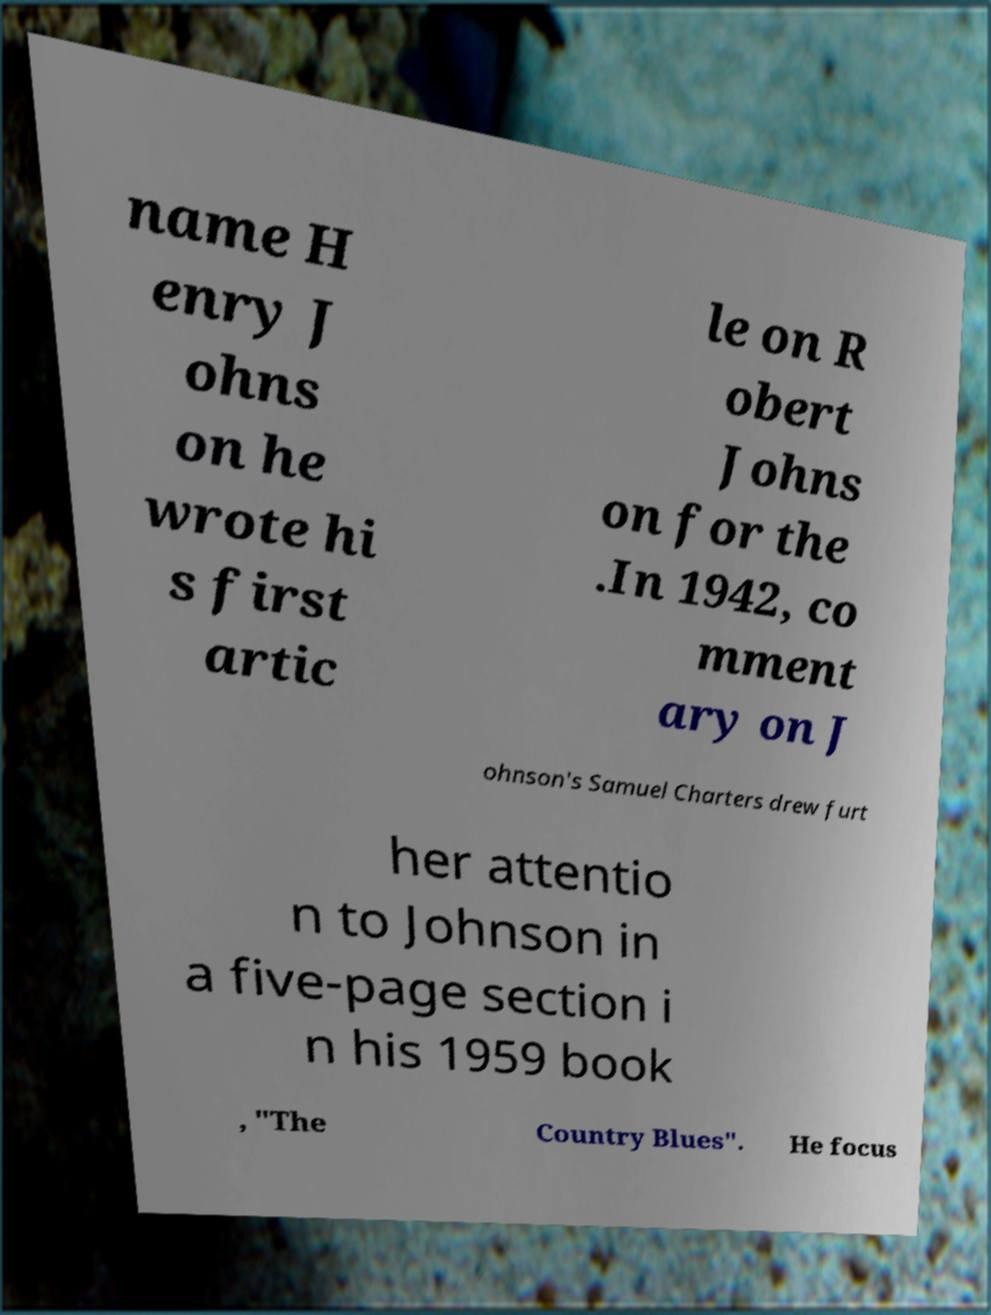What messages or text are displayed in this image? I need them in a readable, typed format. name H enry J ohns on he wrote hi s first artic le on R obert Johns on for the .In 1942, co mment ary on J ohnson's Samuel Charters drew furt her attentio n to Johnson in a five-page section i n his 1959 book , "The Country Blues". He focus 